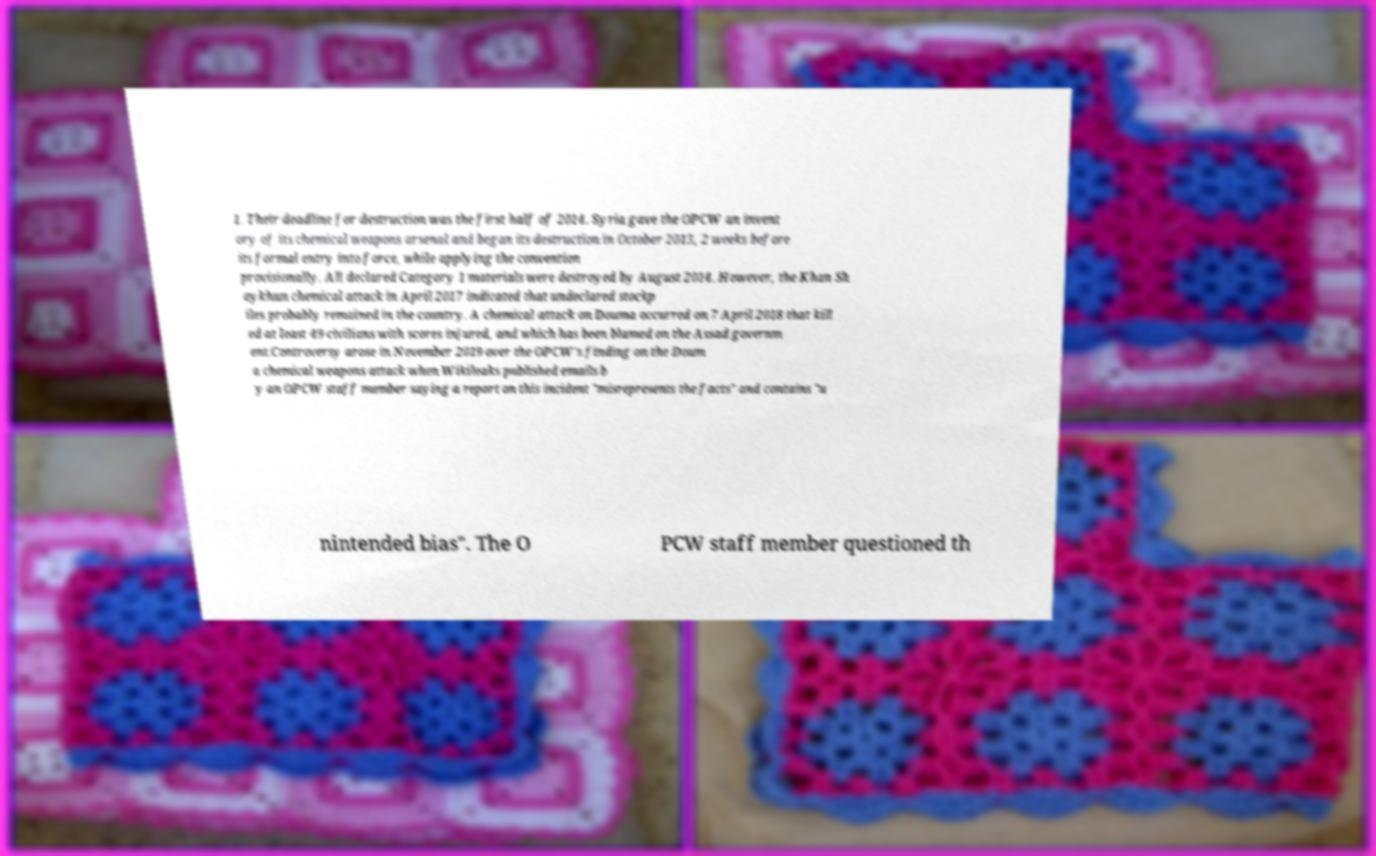What messages or text are displayed in this image? I need them in a readable, typed format. 1. Their deadline for destruction was the first half of 2014. Syria gave the OPCW an invent ory of its chemical weapons arsenal and began its destruction in October 2013, 2 weeks before its formal entry into force, while applying the convention provisionally. All declared Category 1 materials were destroyed by August 2014. However, the Khan Sh aykhun chemical attack in April 2017 indicated that undeclared stockp iles probably remained in the country. A chemical attack on Douma occurred on 7 April 2018 that kill ed at least 49 civilians with scores injured, and which has been blamed on the Assad governm ent.Controversy arose in November 2019 over the OPCW's finding on the Doum a chemical weapons attack when Wikileaks published emails b y an OPCW staff member saying a report on this incident "misrepresents the facts" and contains "u nintended bias". The O PCW staff member questioned th 